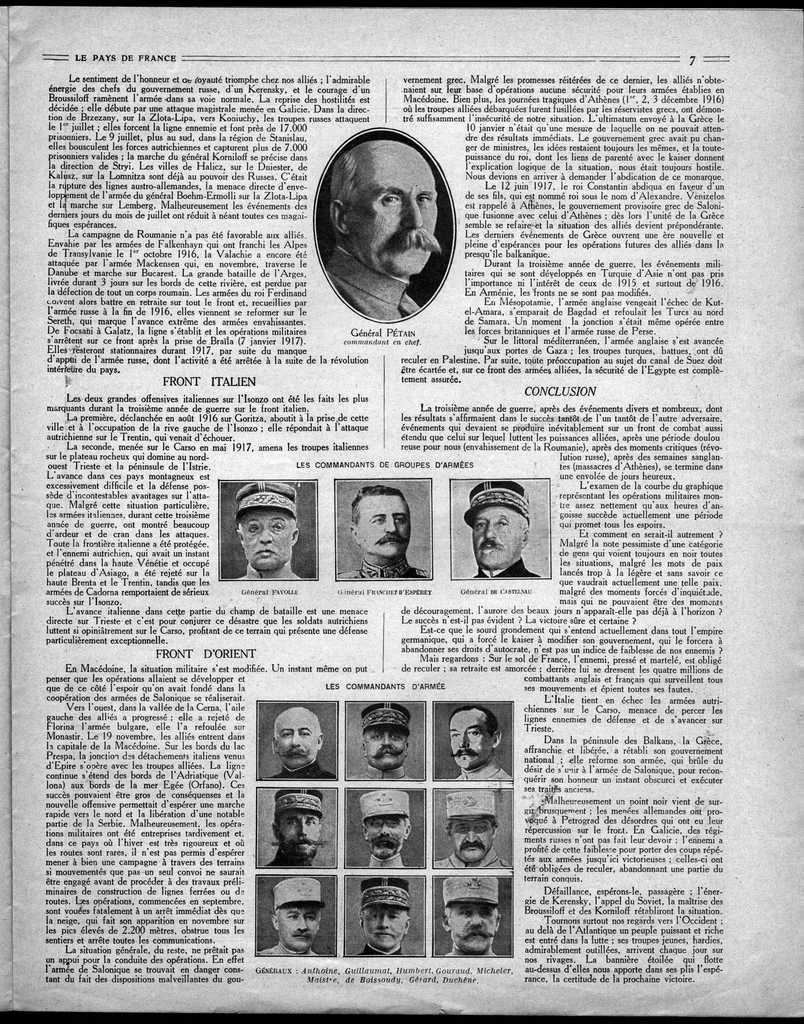Describe this image in one or two sentences. In this picture there is a paper on which we can see the text is printed and we can see the pictures of some persons are also printed on the paper. 